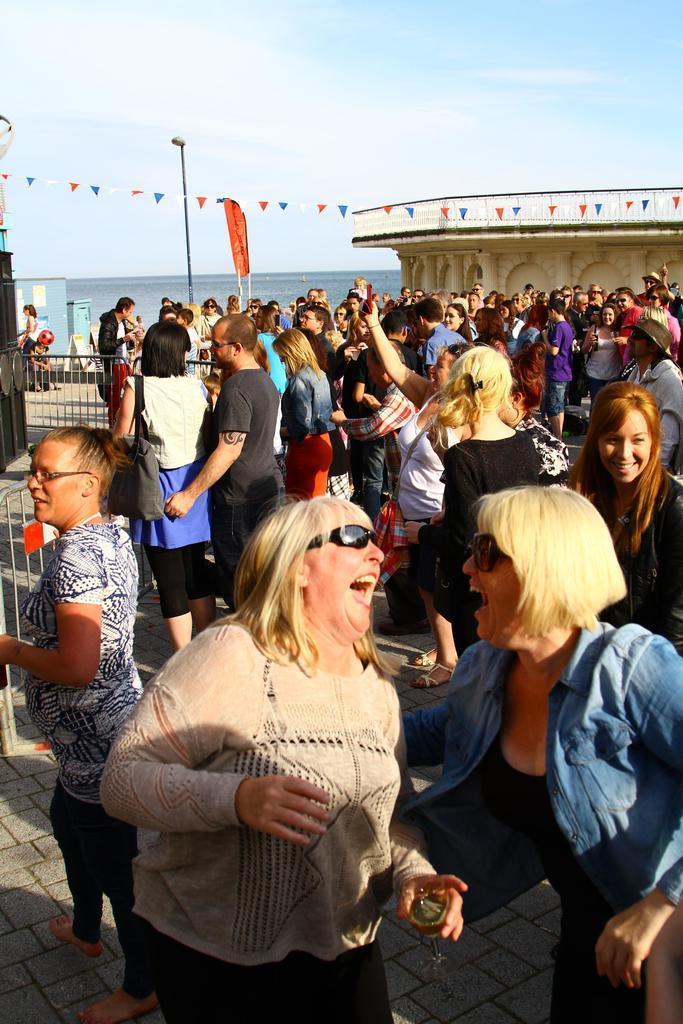Please provide a concise description of this image. In this image I can see a woman wearing cream and black colored dress is standing and holding a glass in her hand and another woman wearing blue and black colored dress is standing and smiling. In the background I can see number of persons standing, the railing, the water, a building and the sky. 